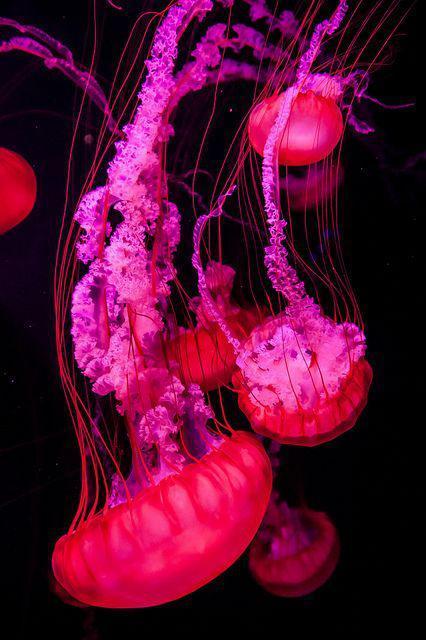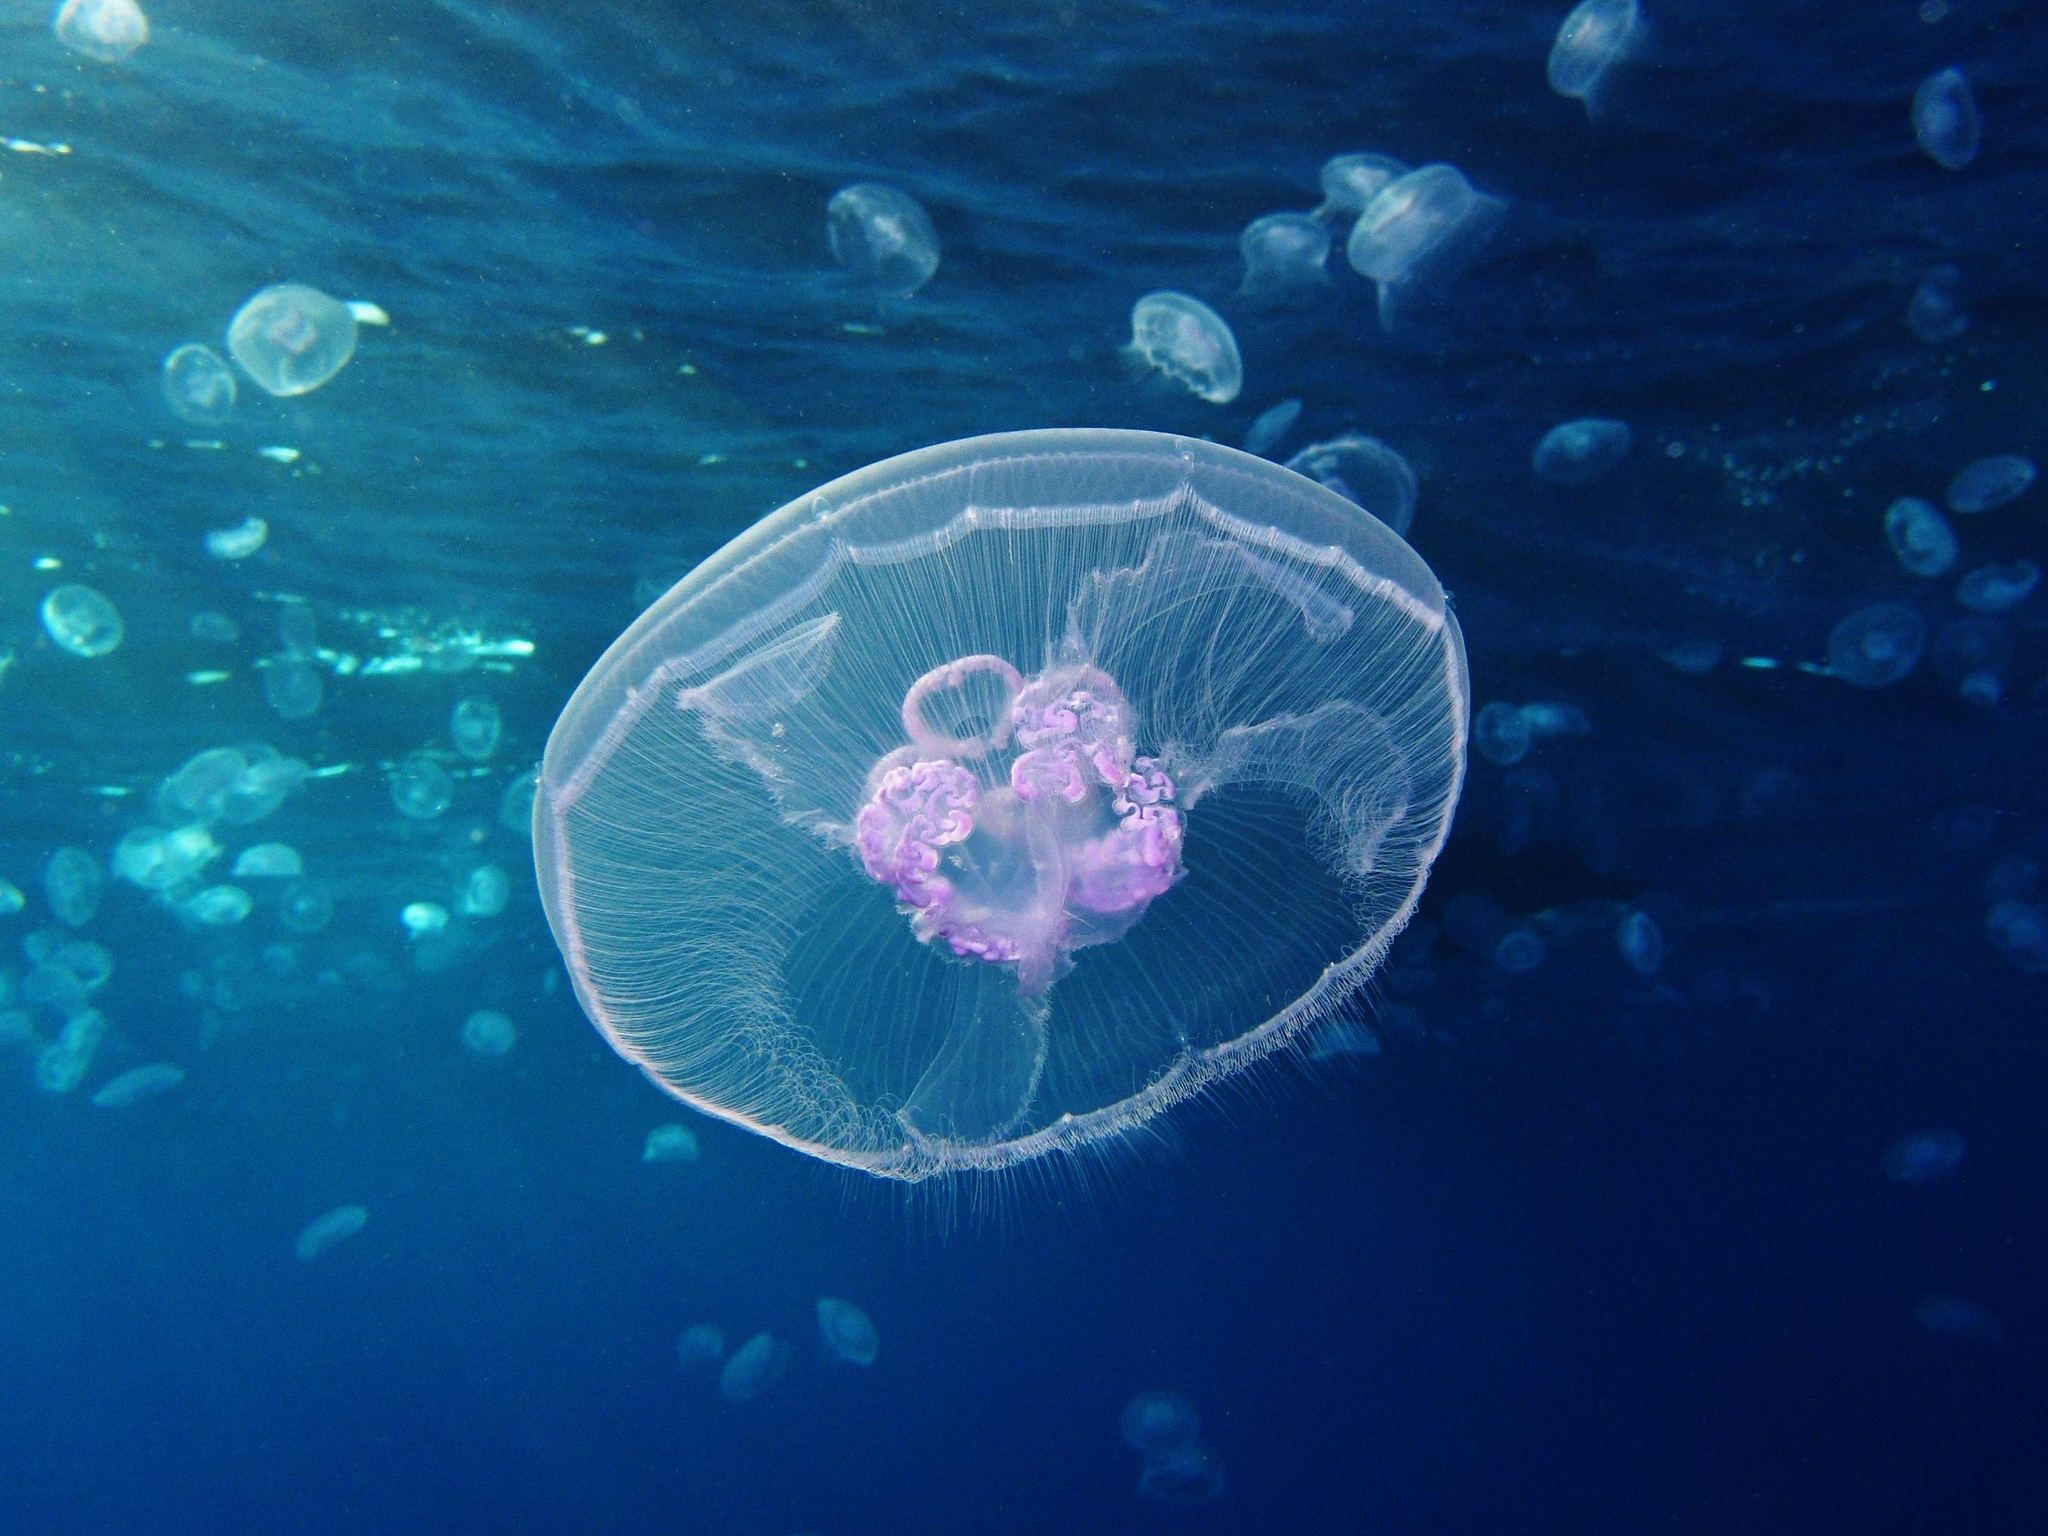The first image is the image on the left, the second image is the image on the right. Examine the images to the left and right. Is the description "An image shows multiple fluorescent pink jellyfish with tendrils trailing upward." accurate? Answer yes or no. Yes. The first image is the image on the left, the second image is the image on the right. For the images displayed, is the sentence "One of the images features exactly one jelly fish." factually correct? Answer yes or no. No. 